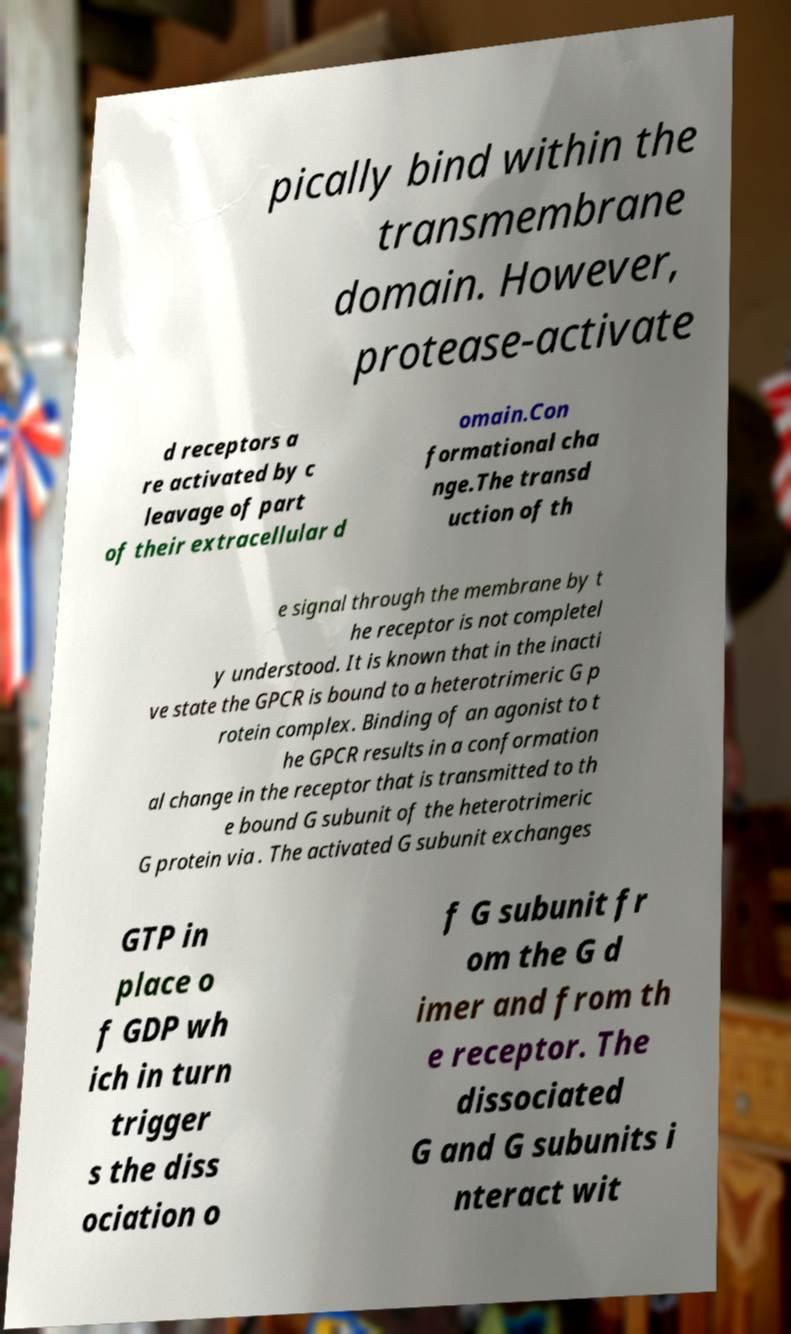Please identify and transcribe the text found in this image. pically bind within the transmembrane domain. However, protease-activate d receptors a re activated by c leavage of part of their extracellular d omain.Con formational cha nge.The transd uction of th e signal through the membrane by t he receptor is not completel y understood. It is known that in the inacti ve state the GPCR is bound to a heterotrimeric G p rotein complex. Binding of an agonist to t he GPCR results in a conformation al change in the receptor that is transmitted to th e bound G subunit of the heterotrimeric G protein via . The activated G subunit exchanges GTP in place o f GDP wh ich in turn trigger s the diss ociation o f G subunit fr om the G d imer and from th e receptor. The dissociated G and G subunits i nteract wit 